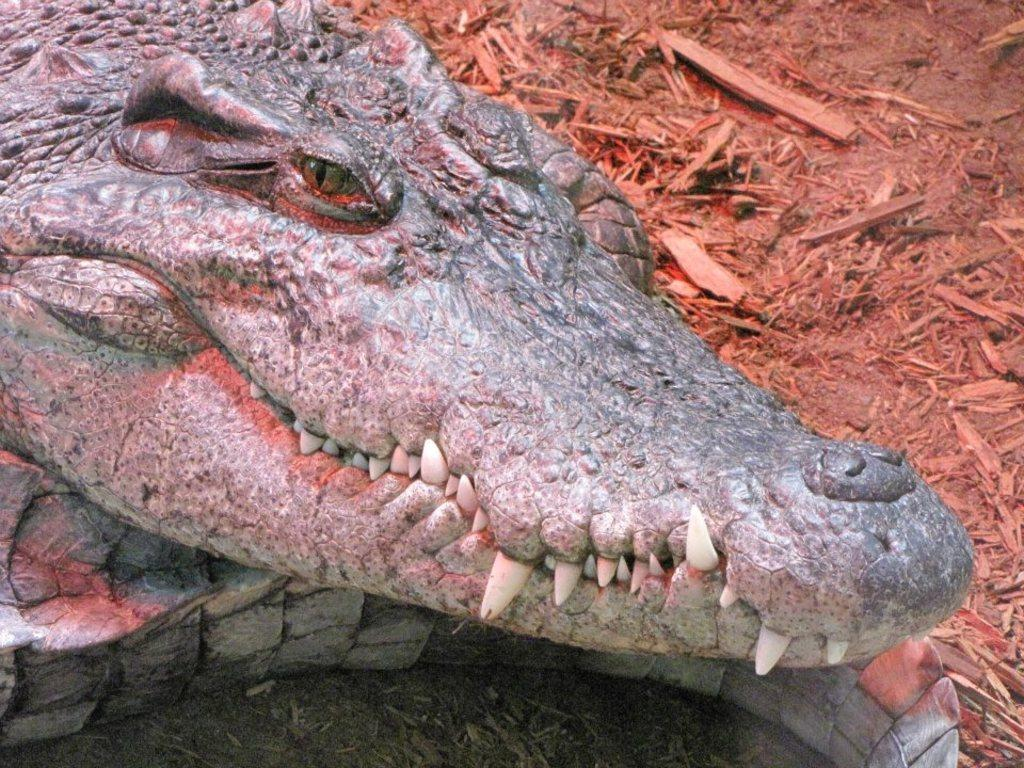Where was the image taken? The image is taken outdoors. What can be seen at the bottom of the image? There is a ground at the bottom of the image. What type of objects are on the ground? There are wooden pieces on the ground. What animal is present on the ground in the image? There is a crocodile on the ground on the left side of the image. What type of club can be seen in the image? There is no club present in the image. How many ants are visible on the wooden pieces in the image? There are no ants visible on the wooden pieces in the image. 